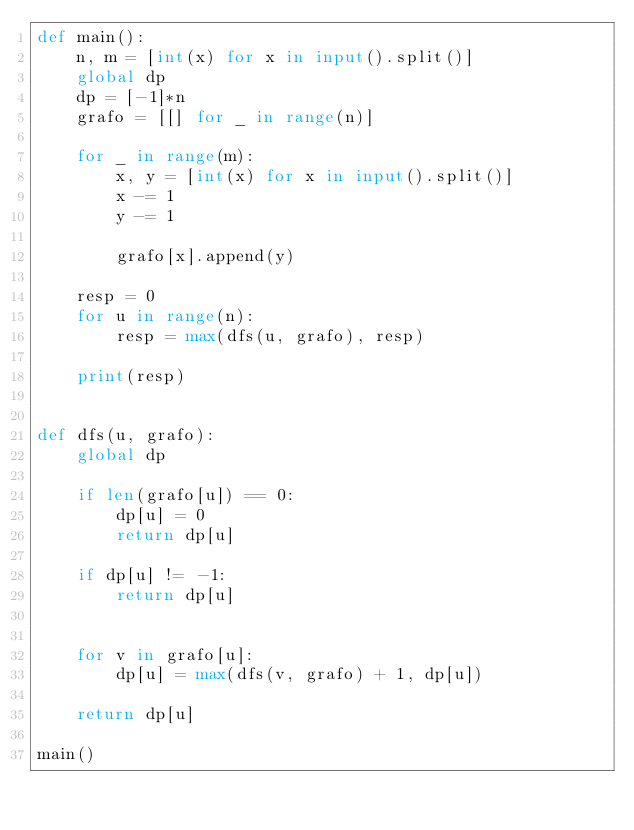<code> <loc_0><loc_0><loc_500><loc_500><_Python_>def main():
    n, m = [int(x) for x in input().split()]
    global dp
    dp = [-1]*n
    grafo = [[] for _ in range(n)]

    for _ in range(m):
        x, y = [int(x) for x in input().split()]
        x -= 1
        y -= 1

        grafo[x].append(y)

    resp = 0
    for u in range(n):
        resp = max(dfs(u, grafo), resp)

    print(resp)
        

def dfs(u, grafo):
    global dp

    if len(grafo[u]) == 0:
        dp[u] = 0
        return dp[u]

    if dp[u] != -1:
        return dp[u]


    for v in grafo[u]:
        dp[u] = max(dfs(v, grafo) + 1, dp[u])

    return dp[u]
        
main()</code> 